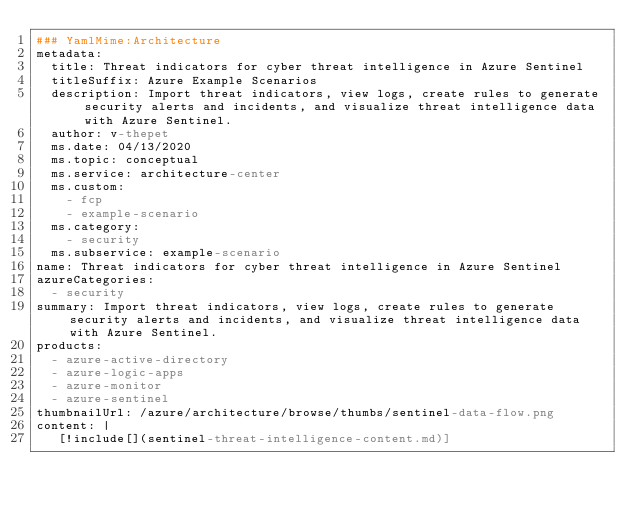Convert code to text. <code><loc_0><loc_0><loc_500><loc_500><_YAML_>### YamlMime:Architecture
metadata:
  title: Threat indicators for cyber threat intelligence in Azure Sentinel
  titleSuffix: Azure Example Scenarios
  description: Import threat indicators, view logs, create rules to generate security alerts and incidents, and visualize threat intelligence data with Azure Sentinel.
  author: v-thepet
  ms.date: 04/13/2020
  ms.topic: conceptual
  ms.service: architecture-center
  ms.custom:
    - fcp
    - example-scenario
  ms.category:
    - security
  ms.subservice: example-scenario
name: Threat indicators for cyber threat intelligence in Azure Sentinel
azureCategories:
  - security
summary: Import threat indicators, view logs, create rules to generate security alerts and incidents, and visualize threat intelligence data with Azure Sentinel.
products:
  - azure-active-directory
  - azure-logic-apps
  - azure-monitor
  - azure-sentinel
thumbnailUrl: /azure/architecture/browse/thumbs/sentinel-data-flow.png
content: |
   [!include[](sentinel-threat-intelligence-content.md)]
</code> 